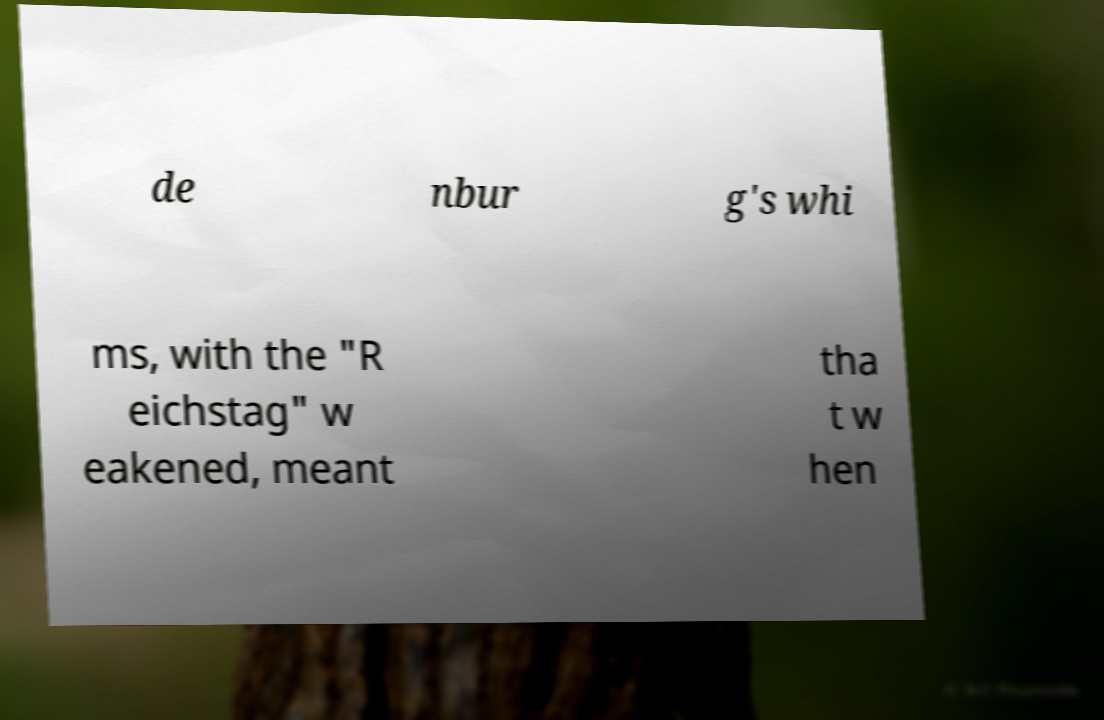Please read and relay the text visible in this image. What does it say? de nbur g's whi ms, with the "R eichstag" w eakened, meant tha t w hen 